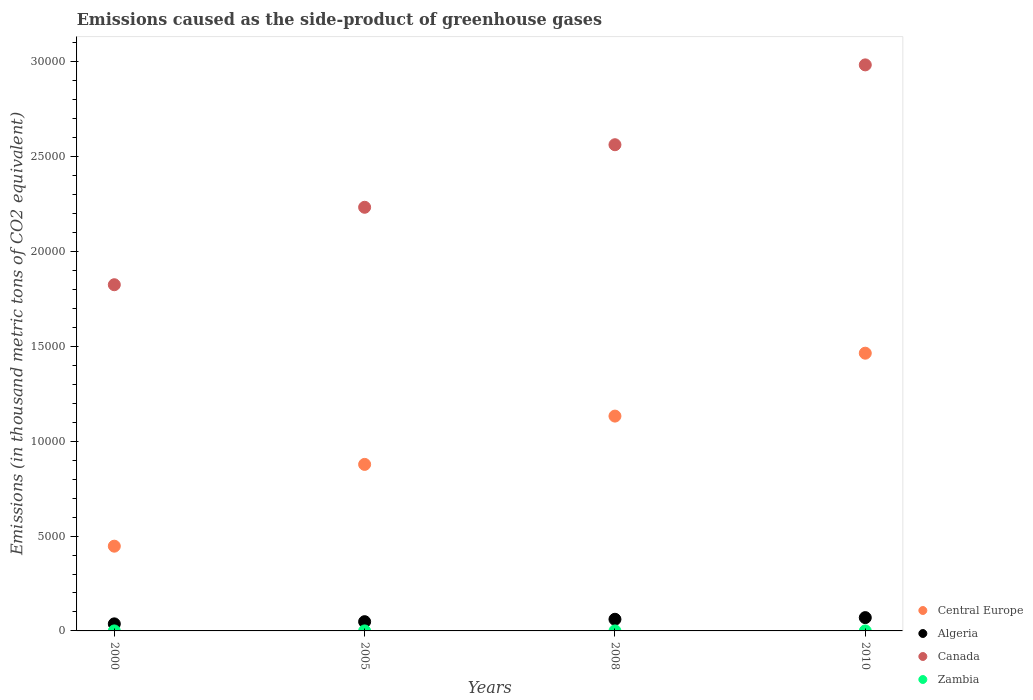What is the emissions caused as the side-product of greenhouse gases in Zambia in 2008?
Give a very brief answer. 0.5. Across all years, what is the maximum emissions caused as the side-product of greenhouse gases in Canada?
Offer a very short reply. 2.98e+04. Across all years, what is the minimum emissions caused as the side-product of greenhouse gases in Central Europe?
Your answer should be compact. 4466.9. What is the total emissions caused as the side-product of greenhouse gases in Canada in the graph?
Your response must be concise. 9.60e+04. What is the difference between the emissions caused as the side-product of greenhouse gases in Zambia in 2005 and that in 2010?
Keep it short and to the point. -0.6. What is the difference between the emissions caused as the side-product of greenhouse gases in Central Europe in 2005 and the emissions caused as the side-product of greenhouse gases in Algeria in 2000?
Make the answer very short. 8405.7. What is the average emissions caused as the side-product of greenhouse gases in Zambia per year?
Your answer should be compact. 0.5. In the year 2008, what is the difference between the emissions caused as the side-product of greenhouse gases in Algeria and emissions caused as the side-product of greenhouse gases in Zambia?
Give a very brief answer. 613.4. In how many years, is the emissions caused as the side-product of greenhouse gases in Zambia greater than 8000 thousand metric tons?
Your answer should be very brief. 0. What is the ratio of the emissions caused as the side-product of greenhouse gases in Central Europe in 2005 to that in 2010?
Your answer should be very brief. 0.6. What is the difference between the highest and the second highest emissions caused as the side-product of greenhouse gases in Canada?
Your answer should be very brief. 4208.7. What is the difference between the highest and the lowest emissions caused as the side-product of greenhouse gases in Canada?
Your answer should be compact. 1.16e+04. In how many years, is the emissions caused as the side-product of greenhouse gases in Canada greater than the average emissions caused as the side-product of greenhouse gases in Canada taken over all years?
Your answer should be compact. 2. Is the sum of the emissions caused as the side-product of greenhouse gases in Canada in 2008 and 2010 greater than the maximum emissions caused as the side-product of greenhouse gases in Algeria across all years?
Provide a short and direct response. Yes. Is the emissions caused as the side-product of greenhouse gases in Zambia strictly greater than the emissions caused as the side-product of greenhouse gases in Algeria over the years?
Your answer should be compact. No. Is the emissions caused as the side-product of greenhouse gases in Zambia strictly less than the emissions caused as the side-product of greenhouse gases in Central Europe over the years?
Your response must be concise. Yes. How many dotlines are there?
Provide a succinct answer. 4. How many years are there in the graph?
Your answer should be very brief. 4. What is the difference between two consecutive major ticks on the Y-axis?
Give a very brief answer. 5000. Does the graph contain grids?
Offer a very short reply. No. Where does the legend appear in the graph?
Provide a short and direct response. Bottom right. How are the legend labels stacked?
Provide a short and direct response. Vertical. What is the title of the graph?
Ensure brevity in your answer.  Emissions caused as the side-product of greenhouse gases. Does "Lithuania" appear as one of the legend labels in the graph?
Provide a succinct answer. No. What is the label or title of the X-axis?
Give a very brief answer. Years. What is the label or title of the Y-axis?
Provide a short and direct response. Emissions (in thousand metric tons of CO2 equivalent). What is the Emissions (in thousand metric tons of CO2 equivalent) of Central Europe in 2000?
Provide a short and direct response. 4466.9. What is the Emissions (in thousand metric tons of CO2 equivalent) of Algeria in 2000?
Make the answer very short. 371.9. What is the Emissions (in thousand metric tons of CO2 equivalent) in Canada in 2000?
Keep it short and to the point. 1.82e+04. What is the Emissions (in thousand metric tons of CO2 equivalent) of Central Europe in 2005?
Make the answer very short. 8777.6. What is the Emissions (in thousand metric tons of CO2 equivalent) of Algeria in 2005?
Offer a terse response. 487.4. What is the Emissions (in thousand metric tons of CO2 equivalent) of Canada in 2005?
Ensure brevity in your answer.  2.23e+04. What is the Emissions (in thousand metric tons of CO2 equivalent) of Central Europe in 2008?
Offer a terse response. 1.13e+04. What is the Emissions (in thousand metric tons of CO2 equivalent) in Algeria in 2008?
Offer a very short reply. 613.9. What is the Emissions (in thousand metric tons of CO2 equivalent) in Canada in 2008?
Your response must be concise. 2.56e+04. What is the Emissions (in thousand metric tons of CO2 equivalent) of Central Europe in 2010?
Keep it short and to the point. 1.46e+04. What is the Emissions (in thousand metric tons of CO2 equivalent) in Algeria in 2010?
Offer a very short reply. 701. What is the Emissions (in thousand metric tons of CO2 equivalent) of Canada in 2010?
Offer a terse response. 2.98e+04. Across all years, what is the maximum Emissions (in thousand metric tons of CO2 equivalent) in Central Europe?
Ensure brevity in your answer.  1.46e+04. Across all years, what is the maximum Emissions (in thousand metric tons of CO2 equivalent) in Algeria?
Your response must be concise. 701. Across all years, what is the maximum Emissions (in thousand metric tons of CO2 equivalent) in Canada?
Your answer should be very brief. 2.98e+04. Across all years, what is the maximum Emissions (in thousand metric tons of CO2 equivalent) of Zambia?
Make the answer very short. 1. Across all years, what is the minimum Emissions (in thousand metric tons of CO2 equivalent) in Central Europe?
Provide a succinct answer. 4466.9. Across all years, what is the minimum Emissions (in thousand metric tons of CO2 equivalent) in Algeria?
Your answer should be compact. 371.9. Across all years, what is the minimum Emissions (in thousand metric tons of CO2 equivalent) in Canada?
Keep it short and to the point. 1.82e+04. What is the total Emissions (in thousand metric tons of CO2 equivalent) of Central Europe in the graph?
Ensure brevity in your answer.  3.92e+04. What is the total Emissions (in thousand metric tons of CO2 equivalent) in Algeria in the graph?
Keep it short and to the point. 2174.2. What is the total Emissions (in thousand metric tons of CO2 equivalent) in Canada in the graph?
Ensure brevity in your answer.  9.60e+04. What is the total Emissions (in thousand metric tons of CO2 equivalent) in Zambia in the graph?
Provide a short and direct response. 2. What is the difference between the Emissions (in thousand metric tons of CO2 equivalent) in Central Europe in 2000 and that in 2005?
Provide a succinct answer. -4310.7. What is the difference between the Emissions (in thousand metric tons of CO2 equivalent) of Algeria in 2000 and that in 2005?
Ensure brevity in your answer.  -115.5. What is the difference between the Emissions (in thousand metric tons of CO2 equivalent) in Canada in 2000 and that in 2005?
Offer a very short reply. -4082.4. What is the difference between the Emissions (in thousand metric tons of CO2 equivalent) of Central Europe in 2000 and that in 2008?
Make the answer very short. -6856.5. What is the difference between the Emissions (in thousand metric tons of CO2 equivalent) of Algeria in 2000 and that in 2008?
Keep it short and to the point. -242. What is the difference between the Emissions (in thousand metric tons of CO2 equivalent) in Canada in 2000 and that in 2008?
Your response must be concise. -7379.5. What is the difference between the Emissions (in thousand metric tons of CO2 equivalent) of Zambia in 2000 and that in 2008?
Your answer should be compact. -0.4. What is the difference between the Emissions (in thousand metric tons of CO2 equivalent) in Central Europe in 2000 and that in 2010?
Your answer should be very brief. -1.02e+04. What is the difference between the Emissions (in thousand metric tons of CO2 equivalent) of Algeria in 2000 and that in 2010?
Offer a very short reply. -329.1. What is the difference between the Emissions (in thousand metric tons of CO2 equivalent) in Canada in 2000 and that in 2010?
Provide a succinct answer. -1.16e+04. What is the difference between the Emissions (in thousand metric tons of CO2 equivalent) of Zambia in 2000 and that in 2010?
Keep it short and to the point. -0.9. What is the difference between the Emissions (in thousand metric tons of CO2 equivalent) of Central Europe in 2005 and that in 2008?
Ensure brevity in your answer.  -2545.8. What is the difference between the Emissions (in thousand metric tons of CO2 equivalent) in Algeria in 2005 and that in 2008?
Provide a short and direct response. -126.5. What is the difference between the Emissions (in thousand metric tons of CO2 equivalent) in Canada in 2005 and that in 2008?
Provide a succinct answer. -3297.1. What is the difference between the Emissions (in thousand metric tons of CO2 equivalent) of Zambia in 2005 and that in 2008?
Your response must be concise. -0.1. What is the difference between the Emissions (in thousand metric tons of CO2 equivalent) of Central Europe in 2005 and that in 2010?
Keep it short and to the point. -5861.4. What is the difference between the Emissions (in thousand metric tons of CO2 equivalent) in Algeria in 2005 and that in 2010?
Ensure brevity in your answer.  -213.6. What is the difference between the Emissions (in thousand metric tons of CO2 equivalent) in Canada in 2005 and that in 2010?
Offer a terse response. -7505.8. What is the difference between the Emissions (in thousand metric tons of CO2 equivalent) of Zambia in 2005 and that in 2010?
Your answer should be very brief. -0.6. What is the difference between the Emissions (in thousand metric tons of CO2 equivalent) in Central Europe in 2008 and that in 2010?
Your answer should be very brief. -3315.6. What is the difference between the Emissions (in thousand metric tons of CO2 equivalent) in Algeria in 2008 and that in 2010?
Provide a succinct answer. -87.1. What is the difference between the Emissions (in thousand metric tons of CO2 equivalent) in Canada in 2008 and that in 2010?
Your answer should be compact. -4208.7. What is the difference between the Emissions (in thousand metric tons of CO2 equivalent) of Zambia in 2008 and that in 2010?
Provide a short and direct response. -0.5. What is the difference between the Emissions (in thousand metric tons of CO2 equivalent) of Central Europe in 2000 and the Emissions (in thousand metric tons of CO2 equivalent) of Algeria in 2005?
Offer a very short reply. 3979.5. What is the difference between the Emissions (in thousand metric tons of CO2 equivalent) of Central Europe in 2000 and the Emissions (in thousand metric tons of CO2 equivalent) of Canada in 2005?
Your answer should be compact. -1.79e+04. What is the difference between the Emissions (in thousand metric tons of CO2 equivalent) in Central Europe in 2000 and the Emissions (in thousand metric tons of CO2 equivalent) in Zambia in 2005?
Make the answer very short. 4466.5. What is the difference between the Emissions (in thousand metric tons of CO2 equivalent) in Algeria in 2000 and the Emissions (in thousand metric tons of CO2 equivalent) in Canada in 2005?
Your answer should be compact. -2.20e+04. What is the difference between the Emissions (in thousand metric tons of CO2 equivalent) of Algeria in 2000 and the Emissions (in thousand metric tons of CO2 equivalent) of Zambia in 2005?
Provide a succinct answer. 371.5. What is the difference between the Emissions (in thousand metric tons of CO2 equivalent) of Canada in 2000 and the Emissions (in thousand metric tons of CO2 equivalent) of Zambia in 2005?
Give a very brief answer. 1.82e+04. What is the difference between the Emissions (in thousand metric tons of CO2 equivalent) of Central Europe in 2000 and the Emissions (in thousand metric tons of CO2 equivalent) of Algeria in 2008?
Make the answer very short. 3853. What is the difference between the Emissions (in thousand metric tons of CO2 equivalent) of Central Europe in 2000 and the Emissions (in thousand metric tons of CO2 equivalent) of Canada in 2008?
Provide a short and direct response. -2.12e+04. What is the difference between the Emissions (in thousand metric tons of CO2 equivalent) of Central Europe in 2000 and the Emissions (in thousand metric tons of CO2 equivalent) of Zambia in 2008?
Provide a succinct answer. 4466.4. What is the difference between the Emissions (in thousand metric tons of CO2 equivalent) in Algeria in 2000 and the Emissions (in thousand metric tons of CO2 equivalent) in Canada in 2008?
Give a very brief answer. -2.53e+04. What is the difference between the Emissions (in thousand metric tons of CO2 equivalent) of Algeria in 2000 and the Emissions (in thousand metric tons of CO2 equivalent) of Zambia in 2008?
Ensure brevity in your answer.  371.4. What is the difference between the Emissions (in thousand metric tons of CO2 equivalent) in Canada in 2000 and the Emissions (in thousand metric tons of CO2 equivalent) in Zambia in 2008?
Your answer should be very brief. 1.82e+04. What is the difference between the Emissions (in thousand metric tons of CO2 equivalent) in Central Europe in 2000 and the Emissions (in thousand metric tons of CO2 equivalent) in Algeria in 2010?
Offer a very short reply. 3765.9. What is the difference between the Emissions (in thousand metric tons of CO2 equivalent) of Central Europe in 2000 and the Emissions (in thousand metric tons of CO2 equivalent) of Canada in 2010?
Provide a succinct answer. -2.54e+04. What is the difference between the Emissions (in thousand metric tons of CO2 equivalent) in Central Europe in 2000 and the Emissions (in thousand metric tons of CO2 equivalent) in Zambia in 2010?
Give a very brief answer. 4465.9. What is the difference between the Emissions (in thousand metric tons of CO2 equivalent) of Algeria in 2000 and the Emissions (in thousand metric tons of CO2 equivalent) of Canada in 2010?
Make the answer very short. -2.95e+04. What is the difference between the Emissions (in thousand metric tons of CO2 equivalent) of Algeria in 2000 and the Emissions (in thousand metric tons of CO2 equivalent) of Zambia in 2010?
Give a very brief answer. 370.9. What is the difference between the Emissions (in thousand metric tons of CO2 equivalent) of Canada in 2000 and the Emissions (in thousand metric tons of CO2 equivalent) of Zambia in 2010?
Ensure brevity in your answer.  1.82e+04. What is the difference between the Emissions (in thousand metric tons of CO2 equivalent) in Central Europe in 2005 and the Emissions (in thousand metric tons of CO2 equivalent) in Algeria in 2008?
Provide a succinct answer. 8163.7. What is the difference between the Emissions (in thousand metric tons of CO2 equivalent) in Central Europe in 2005 and the Emissions (in thousand metric tons of CO2 equivalent) in Canada in 2008?
Provide a succinct answer. -1.68e+04. What is the difference between the Emissions (in thousand metric tons of CO2 equivalent) in Central Europe in 2005 and the Emissions (in thousand metric tons of CO2 equivalent) in Zambia in 2008?
Your answer should be compact. 8777.1. What is the difference between the Emissions (in thousand metric tons of CO2 equivalent) in Algeria in 2005 and the Emissions (in thousand metric tons of CO2 equivalent) in Canada in 2008?
Your response must be concise. -2.51e+04. What is the difference between the Emissions (in thousand metric tons of CO2 equivalent) in Algeria in 2005 and the Emissions (in thousand metric tons of CO2 equivalent) in Zambia in 2008?
Provide a short and direct response. 486.9. What is the difference between the Emissions (in thousand metric tons of CO2 equivalent) of Canada in 2005 and the Emissions (in thousand metric tons of CO2 equivalent) of Zambia in 2008?
Provide a succinct answer. 2.23e+04. What is the difference between the Emissions (in thousand metric tons of CO2 equivalent) in Central Europe in 2005 and the Emissions (in thousand metric tons of CO2 equivalent) in Algeria in 2010?
Provide a short and direct response. 8076.6. What is the difference between the Emissions (in thousand metric tons of CO2 equivalent) in Central Europe in 2005 and the Emissions (in thousand metric tons of CO2 equivalent) in Canada in 2010?
Offer a very short reply. -2.11e+04. What is the difference between the Emissions (in thousand metric tons of CO2 equivalent) in Central Europe in 2005 and the Emissions (in thousand metric tons of CO2 equivalent) in Zambia in 2010?
Offer a very short reply. 8776.6. What is the difference between the Emissions (in thousand metric tons of CO2 equivalent) of Algeria in 2005 and the Emissions (in thousand metric tons of CO2 equivalent) of Canada in 2010?
Provide a short and direct response. -2.93e+04. What is the difference between the Emissions (in thousand metric tons of CO2 equivalent) in Algeria in 2005 and the Emissions (in thousand metric tons of CO2 equivalent) in Zambia in 2010?
Keep it short and to the point. 486.4. What is the difference between the Emissions (in thousand metric tons of CO2 equivalent) in Canada in 2005 and the Emissions (in thousand metric tons of CO2 equivalent) in Zambia in 2010?
Your response must be concise. 2.23e+04. What is the difference between the Emissions (in thousand metric tons of CO2 equivalent) in Central Europe in 2008 and the Emissions (in thousand metric tons of CO2 equivalent) in Algeria in 2010?
Offer a terse response. 1.06e+04. What is the difference between the Emissions (in thousand metric tons of CO2 equivalent) in Central Europe in 2008 and the Emissions (in thousand metric tons of CO2 equivalent) in Canada in 2010?
Provide a succinct answer. -1.85e+04. What is the difference between the Emissions (in thousand metric tons of CO2 equivalent) of Central Europe in 2008 and the Emissions (in thousand metric tons of CO2 equivalent) of Zambia in 2010?
Provide a short and direct response. 1.13e+04. What is the difference between the Emissions (in thousand metric tons of CO2 equivalent) of Algeria in 2008 and the Emissions (in thousand metric tons of CO2 equivalent) of Canada in 2010?
Provide a short and direct response. -2.92e+04. What is the difference between the Emissions (in thousand metric tons of CO2 equivalent) in Algeria in 2008 and the Emissions (in thousand metric tons of CO2 equivalent) in Zambia in 2010?
Provide a succinct answer. 612.9. What is the difference between the Emissions (in thousand metric tons of CO2 equivalent) in Canada in 2008 and the Emissions (in thousand metric tons of CO2 equivalent) in Zambia in 2010?
Your answer should be compact. 2.56e+04. What is the average Emissions (in thousand metric tons of CO2 equivalent) of Central Europe per year?
Provide a succinct answer. 9801.73. What is the average Emissions (in thousand metric tons of CO2 equivalent) of Algeria per year?
Ensure brevity in your answer.  543.55. What is the average Emissions (in thousand metric tons of CO2 equivalent) of Canada per year?
Offer a terse response. 2.40e+04. In the year 2000, what is the difference between the Emissions (in thousand metric tons of CO2 equivalent) of Central Europe and Emissions (in thousand metric tons of CO2 equivalent) of Algeria?
Keep it short and to the point. 4095. In the year 2000, what is the difference between the Emissions (in thousand metric tons of CO2 equivalent) of Central Europe and Emissions (in thousand metric tons of CO2 equivalent) of Canada?
Make the answer very short. -1.38e+04. In the year 2000, what is the difference between the Emissions (in thousand metric tons of CO2 equivalent) in Central Europe and Emissions (in thousand metric tons of CO2 equivalent) in Zambia?
Your response must be concise. 4466.8. In the year 2000, what is the difference between the Emissions (in thousand metric tons of CO2 equivalent) in Algeria and Emissions (in thousand metric tons of CO2 equivalent) in Canada?
Keep it short and to the point. -1.79e+04. In the year 2000, what is the difference between the Emissions (in thousand metric tons of CO2 equivalent) in Algeria and Emissions (in thousand metric tons of CO2 equivalent) in Zambia?
Keep it short and to the point. 371.8. In the year 2000, what is the difference between the Emissions (in thousand metric tons of CO2 equivalent) of Canada and Emissions (in thousand metric tons of CO2 equivalent) of Zambia?
Your response must be concise. 1.82e+04. In the year 2005, what is the difference between the Emissions (in thousand metric tons of CO2 equivalent) of Central Europe and Emissions (in thousand metric tons of CO2 equivalent) of Algeria?
Provide a short and direct response. 8290.2. In the year 2005, what is the difference between the Emissions (in thousand metric tons of CO2 equivalent) in Central Europe and Emissions (in thousand metric tons of CO2 equivalent) in Canada?
Give a very brief answer. -1.36e+04. In the year 2005, what is the difference between the Emissions (in thousand metric tons of CO2 equivalent) in Central Europe and Emissions (in thousand metric tons of CO2 equivalent) in Zambia?
Your answer should be compact. 8777.2. In the year 2005, what is the difference between the Emissions (in thousand metric tons of CO2 equivalent) of Algeria and Emissions (in thousand metric tons of CO2 equivalent) of Canada?
Provide a short and direct response. -2.18e+04. In the year 2005, what is the difference between the Emissions (in thousand metric tons of CO2 equivalent) of Algeria and Emissions (in thousand metric tons of CO2 equivalent) of Zambia?
Offer a very short reply. 487. In the year 2005, what is the difference between the Emissions (in thousand metric tons of CO2 equivalent) of Canada and Emissions (in thousand metric tons of CO2 equivalent) of Zambia?
Provide a short and direct response. 2.23e+04. In the year 2008, what is the difference between the Emissions (in thousand metric tons of CO2 equivalent) in Central Europe and Emissions (in thousand metric tons of CO2 equivalent) in Algeria?
Offer a very short reply. 1.07e+04. In the year 2008, what is the difference between the Emissions (in thousand metric tons of CO2 equivalent) in Central Europe and Emissions (in thousand metric tons of CO2 equivalent) in Canada?
Give a very brief answer. -1.43e+04. In the year 2008, what is the difference between the Emissions (in thousand metric tons of CO2 equivalent) of Central Europe and Emissions (in thousand metric tons of CO2 equivalent) of Zambia?
Give a very brief answer. 1.13e+04. In the year 2008, what is the difference between the Emissions (in thousand metric tons of CO2 equivalent) of Algeria and Emissions (in thousand metric tons of CO2 equivalent) of Canada?
Offer a terse response. -2.50e+04. In the year 2008, what is the difference between the Emissions (in thousand metric tons of CO2 equivalent) in Algeria and Emissions (in thousand metric tons of CO2 equivalent) in Zambia?
Ensure brevity in your answer.  613.4. In the year 2008, what is the difference between the Emissions (in thousand metric tons of CO2 equivalent) of Canada and Emissions (in thousand metric tons of CO2 equivalent) of Zambia?
Make the answer very short. 2.56e+04. In the year 2010, what is the difference between the Emissions (in thousand metric tons of CO2 equivalent) in Central Europe and Emissions (in thousand metric tons of CO2 equivalent) in Algeria?
Ensure brevity in your answer.  1.39e+04. In the year 2010, what is the difference between the Emissions (in thousand metric tons of CO2 equivalent) in Central Europe and Emissions (in thousand metric tons of CO2 equivalent) in Canada?
Your answer should be very brief. -1.52e+04. In the year 2010, what is the difference between the Emissions (in thousand metric tons of CO2 equivalent) of Central Europe and Emissions (in thousand metric tons of CO2 equivalent) of Zambia?
Ensure brevity in your answer.  1.46e+04. In the year 2010, what is the difference between the Emissions (in thousand metric tons of CO2 equivalent) in Algeria and Emissions (in thousand metric tons of CO2 equivalent) in Canada?
Your response must be concise. -2.91e+04. In the year 2010, what is the difference between the Emissions (in thousand metric tons of CO2 equivalent) in Algeria and Emissions (in thousand metric tons of CO2 equivalent) in Zambia?
Your answer should be very brief. 700. In the year 2010, what is the difference between the Emissions (in thousand metric tons of CO2 equivalent) of Canada and Emissions (in thousand metric tons of CO2 equivalent) of Zambia?
Provide a short and direct response. 2.98e+04. What is the ratio of the Emissions (in thousand metric tons of CO2 equivalent) in Central Europe in 2000 to that in 2005?
Your answer should be very brief. 0.51. What is the ratio of the Emissions (in thousand metric tons of CO2 equivalent) of Algeria in 2000 to that in 2005?
Your answer should be very brief. 0.76. What is the ratio of the Emissions (in thousand metric tons of CO2 equivalent) in Canada in 2000 to that in 2005?
Provide a short and direct response. 0.82. What is the ratio of the Emissions (in thousand metric tons of CO2 equivalent) of Central Europe in 2000 to that in 2008?
Keep it short and to the point. 0.39. What is the ratio of the Emissions (in thousand metric tons of CO2 equivalent) of Algeria in 2000 to that in 2008?
Provide a short and direct response. 0.61. What is the ratio of the Emissions (in thousand metric tons of CO2 equivalent) in Canada in 2000 to that in 2008?
Your response must be concise. 0.71. What is the ratio of the Emissions (in thousand metric tons of CO2 equivalent) in Central Europe in 2000 to that in 2010?
Your answer should be compact. 0.31. What is the ratio of the Emissions (in thousand metric tons of CO2 equivalent) of Algeria in 2000 to that in 2010?
Keep it short and to the point. 0.53. What is the ratio of the Emissions (in thousand metric tons of CO2 equivalent) of Canada in 2000 to that in 2010?
Make the answer very short. 0.61. What is the ratio of the Emissions (in thousand metric tons of CO2 equivalent) in Central Europe in 2005 to that in 2008?
Ensure brevity in your answer.  0.78. What is the ratio of the Emissions (in thousand metric tons of CO2 equivalent) in Algeria in 2005 to that in 2008?
Provide a short and direct response. 0.79. What is the ratio of the Emissions (in thousand metric tons of CO2 equivalent) in Canada in 2005 to that in 2008?
Your answer should be very brief. 0.87. What is the ratio of the Emissions (in thousand metric tons of CO2 equivalent) of Zambia in 2005 to that in 2008?
Offer a very short reply. 0.8. What is the ratio of the Emissions (in thousand metric tons of CO2 equivalent) in Central Europe in 2005 to that in 2010?
Your answer should be compact. 0.6. What is the ratio of the Emissions (in thousand metric tons of CO2 equivalent) in Algeria in 2005 to that in 2010?
Ensure brevity in your answer.  0.7. What is the ratio of the Emissions (in thousand metric tons of CO2 equivalent) of Canada in 2005 to that in 2010?
Make the answer very short. 0.75. What is the ratio of the Emissions (in thousand metric tons of CO2 equivalent) in Central Europe in 2008 to that in 2010?
Offer a terse response. 0.77. What is the ratio of the Emissions (in thousand metric tons of CO2 equivalent) of Algeria in 2008 to that in 2010?
Give a very brief answer. 0.88. What is the ratio of the Emissions (in thousand metric tons of CO2 equivalent) in Canada in 2008 to that in 2010?
Make the answer very short. 0.86. What is the difference between the highest and the second highest Emissions (in thousand metric tons of CO2 equivalent) of Central Europe?
Provide a short and direct response. 3315.6. What is the difference between the highest and the second highest Emissions (in thousand metric tons of CO2 equivalent) of Algeria?
Offer a terse response. 87.1. What is the difference between the highest and the second highest Emissions (in thousand metric tons of CO2 equivalent) of Canada?
Offer a terse response. 4208.7. What is the difference between the highest and the second highest Emissions (in thousand metric tons of CO2 equivalent) in Zambia?
Your response must be concise. 0.5. What is the difference between the highest and the lowest Emissions (in thousand metric tons of CO2 equivalent) of Central Europe?
Make the answer very short. 1.02e+04. What is the difference between the highest and the lowest Emissions (in thousand metric tons of CO2 equivalent) of Algeria?
Offer a terse response. 329.1. What is the difference between the highest and the lowest Emissions (in thousand metric tons of CO2 equivalent) in Canada?
Provide a succinct answer. 1.16e+04. 